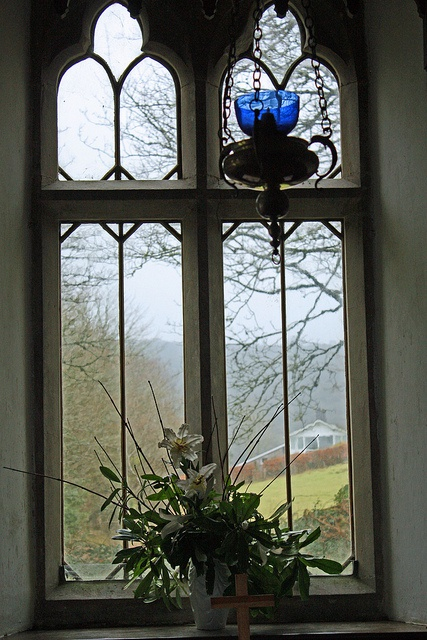Describe the objects in this image and their specific colors. I can see potted plant in black, gray, tan, and darkgreen tones, vase in black, darkgreen, and gray tones, and vase in black, blue, navy, and lightblue tones in this image. 